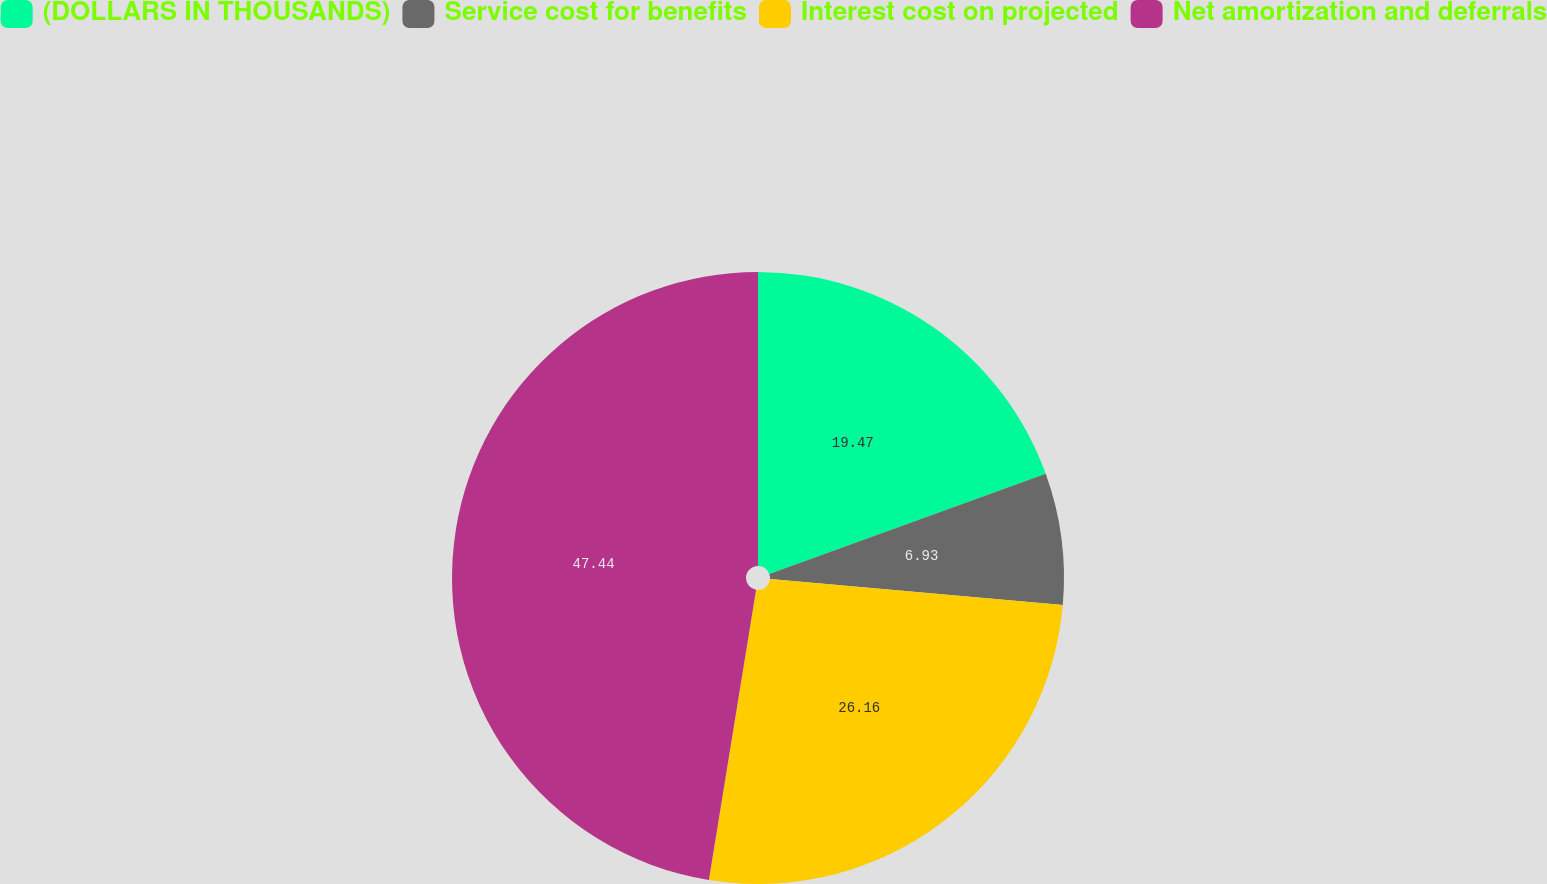<chart> <loc_0><loc_0><loc_500><loc_500><pie_chart><fcel>(DOLLARS IN THOUSANDS)<fcel>Service cost for benefits<fcel>Interest cost on projected<fcel>Net amortization and deferrals<nl><fcel>19.47%<fcel>6.93%<fcel>26.16%<fcel>47.43%<nl></chart> 